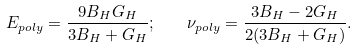Convert formula to latex. <formula><loc_0><loc_0><loc_500><loc_500>E _ { p o l y } = \frac { 9 B _ { H } G _ { H } } { 3 B _ { H } + G _ { H } } ; \quad \nu _ { p o l y } = \frac { 3 B _ { H } - 2 G _ { H } } { 2 ( 3 B _ { H } + G _ { H } ) } .</formula> 